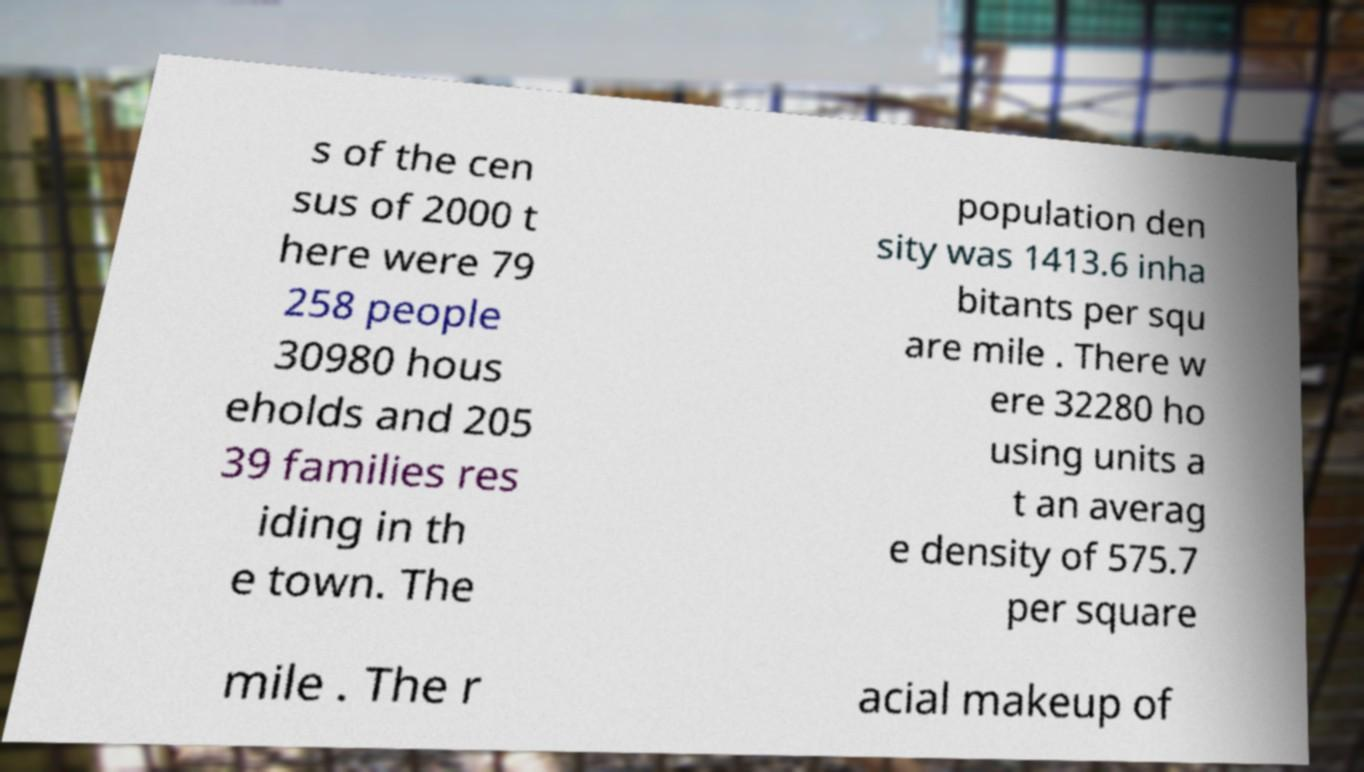What messages or text are displayed in this image? I need them in a readable, typed format. s of the cen sus of 2000 t here were 79 258 people 30980 hous eholds and 205 39 families res iding in th e town. The population den sity was 1413.6 inha bitants per squ are mile . There w ere 32280 ho using units a t an averag e density of 575.7 per square mile . The r acial makeup of 